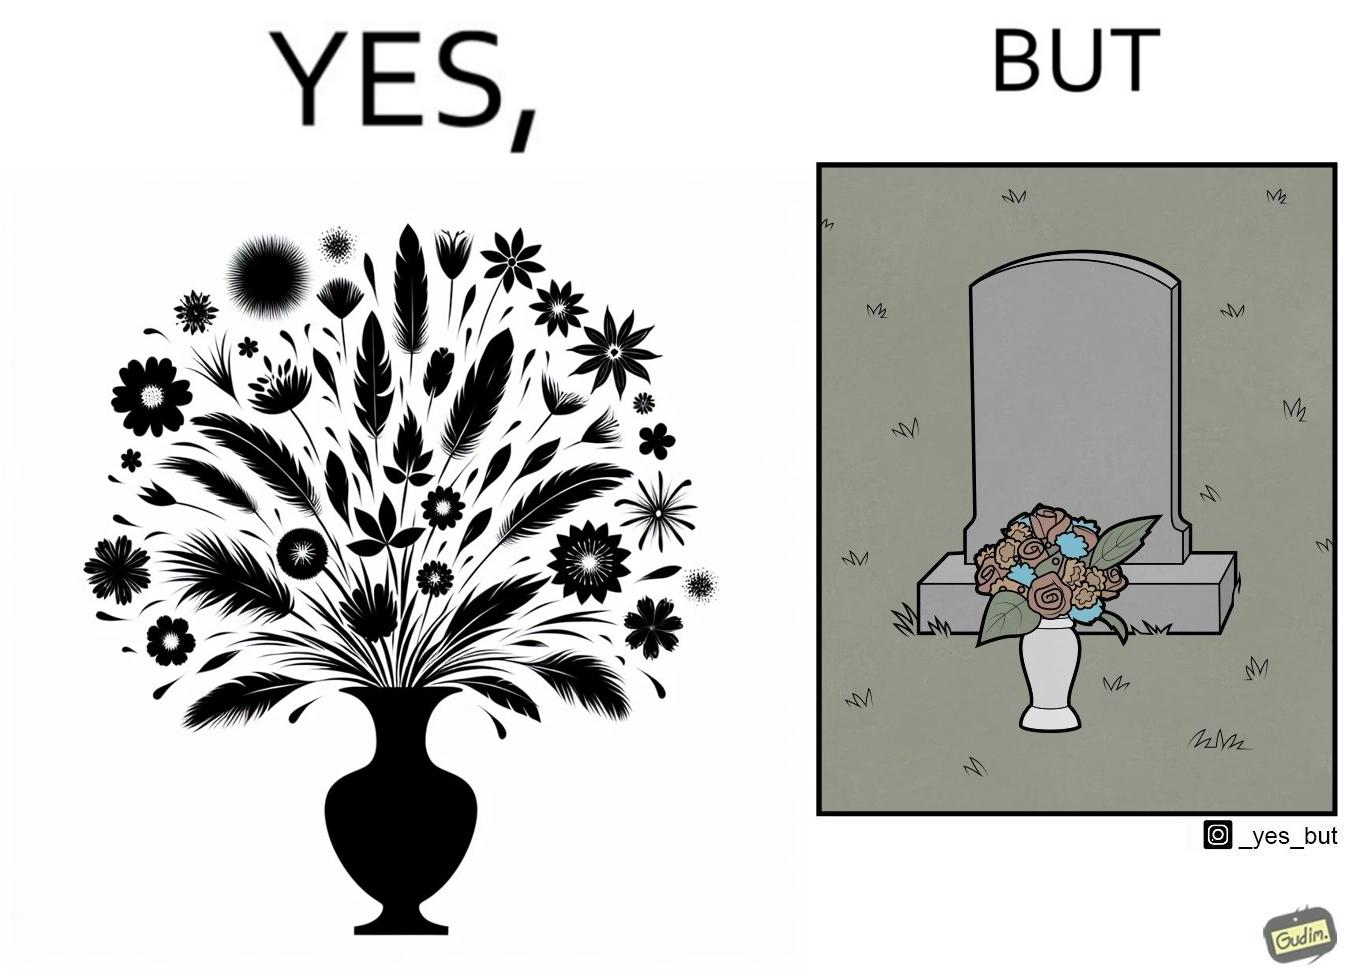Describe what you see in this image. The image is ironic, because in the first image a vase full of different beautiful flowers is seen which spreads a feeling of positivity, cheerfulness etc., whereas in the second image when the same vase is put in front of a grave stone it produces a feeling of sorrow 